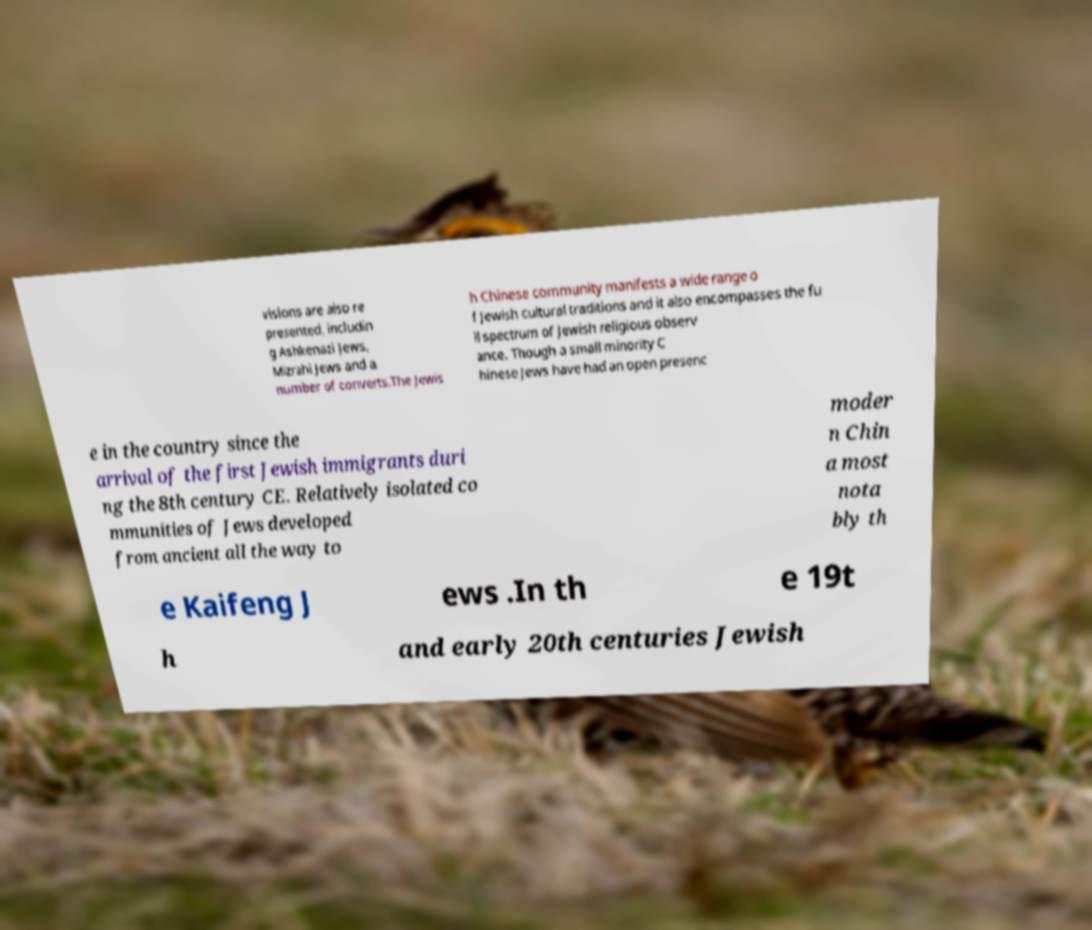There's text embedded in this image that I need extracted. Can you transcribe it verbatim? visions are also re presented, includin g Ashkenazi Jews, Mizrahi Jews and a number of converts.The Jewis h Chinese community manifests a wide range o f Jewish cultural traditions and it also encompasses the fu ll spectrum of Jewish religious observ ance. Though a small minority C hinese Jews have had an open presenc e in the country since the arrival of the first Jewish immigrants duri ng the 8th century CE. Relatively isolated co mmunities of Jews developed from ancient all the way to moder n Chin a most nota bly th e Kaifeng J ews .In th e 19t h and early 20th centuries Jewish 